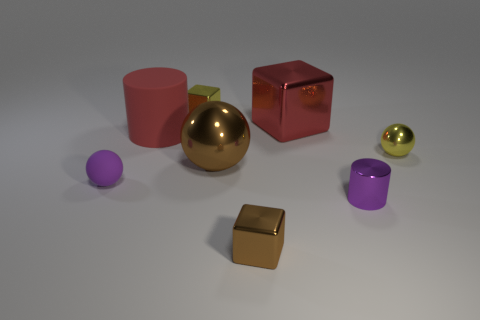How many metal things are the same color as the tiny matte ball?
Offer a very short reply. 1. There is a tiny brown metal object; are there any big rubber objects in front of it?
Ensure brevity in your answer.  No. There is a big matte thing; is it the same shape as the small purple object on the right side of the large sphere?
Your answer should be very brief. Yes. How many objects are small shiny things behind the purple ball or tiny purple matte balls?
Keep it short and to the point. 3. What number of metal things are both behind the red rubber cylinder and left of the big metallic cube?
Keep it short and to the point. 1. What number of objects are tiny yellow metallic objects behind the yellow metallic sphere or tiny metallic things that are behind the big red block?
Provide a short and direct response. 1. How many other things are the same shape as the red metallic object?
Ensure brevity in your answer.  2. There is a matte thing that is in front of the tiny yellow sphere; does it have the same color as the tiny shiny cylinder?
Your response must be concise. Yes. How many other things are there of the same size as the yellow metallic sphere?
Your answer should be very brief. 4. Are the small brown block and the large cylinder made of the same material?
Ensure brevity in your answer.  No. 